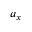Convert formula to latex. <formula><loc_0><loc_0><loc_500><loc_500>a _ { x }</formula> 